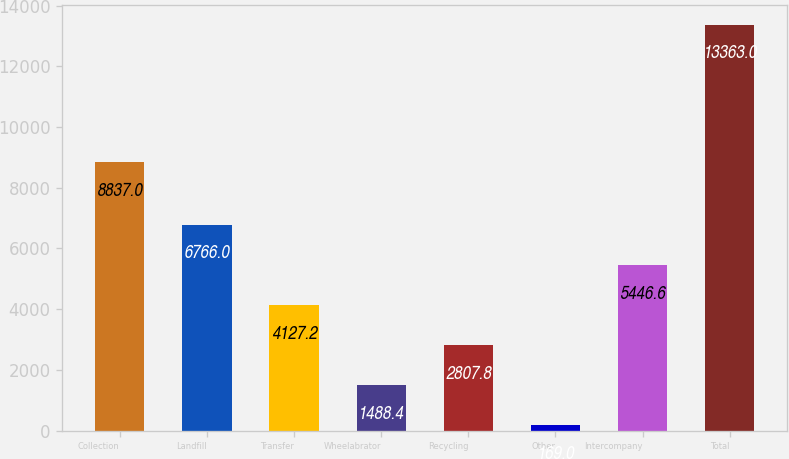Convert chart to OTSL. <chart><loc_0><loc_0><loc_500><loc_500><bar_chart><fcel>Collection<fcel>Landfill<fcel>Transfer<fcel>Wheelabrator<fcel>Recycling<fcel>Other<fcel>Intercompany<fcel>Total<nl><fcel>8837<fcel>6766<fcel>4127.2<fcel>1488.4<fcel>2807.8<fcel>169<fcel>5446.6<fcel>13363<nl></chart> 